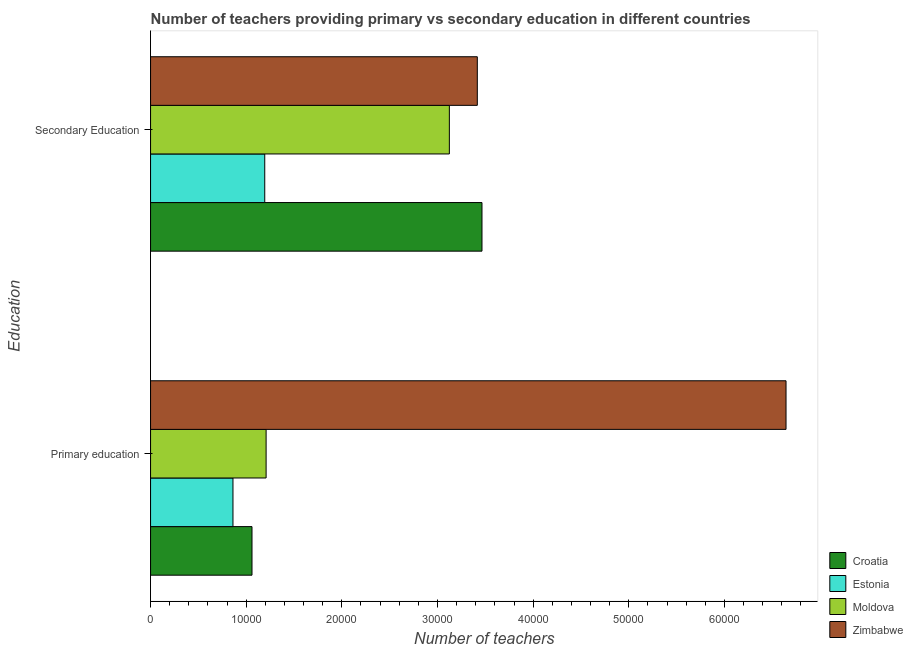How many groups of bars are there?
Your answer should be compact. 2. How many bars are there on the 2nd tick from the top?
Your response must be concise. 4. How many bars are there on the 2nd tick from the bottom?
Your response must be concise. 4. What is the number of primary teachers in Moldova?
Your answer should be compact. 1.21e+04. Across all countries, what is the maximum number of primary teachers?
Keep it short and to the point. 6.64e+04. Across all countries, what is the minimum number of primary teachers?
Give a very brief answer. 8616. In which country was the number of secondary teachers maximum?
Your response must be concise. Croatia. In which country was the number of secondary teachers minimum?
Make the answer very short. Estonia. What is the total number of secondary teachers in the graph?
Offer a terse response. 1.12e+05. What is the difference between the number of secondary teachers in Estonia and the number of primary teachers in Moldova?
Offer a terse response. -142. What is the average number of secondary teachers per country?
Offer a terse response. 2.80e+04. What is the difference between the number of secondary teachers and number of primary teachers in Croatia?
Provide a short and direct response. 2.40e+04. In how many countries, is the number of primary teachers greater than 4000 ?
Provide a succinct answer. 4. What is the ratio of the number of secondary teachers in Moldova to that in Estonia?
Your answer should be compact. 2.62. Is the number of primary teachers in Moldova less than that in Croatia?
Ensure brevity in your answer.  No. In how many countries, is the number of secondary teachers greater than the average number of secondary teachers taken over all countries?
Provide a short and direct response. 3. What does the 4th bar from the top in Primary education represents?
Give a very brief answer. Croatia. What does the 3rd bar from the bottom in Secondary Education represents?
Give a very brief answer. Moldova. Are all the bars in the graph horizontal?
Your response must be concise. Yes. How many countries are there in the graph?
Your answer should be compact. 4. Are the values on the major ticks of X-axis written in scientific E-notation?
Ensure brevity in your answer.  No. Does the graph contain any zero values?
Make the answer very short. No. Does the graph contain grids?
Your answer should be compact. No. Where does the legend appear in the graph?
Give a very brief answer. Bottom right. How are the legend labels stacked?
Your answer should be compact. Vertical. What is the title of the graph?
Offer a very short reply. Number of teachers providing primary vs secondary education in different countries. What is the label or title of the X-axis?
Keep it short and to the point. Number of teachers. What is the label or title of the Y-axis?
Your response must be concise. Education. What is the Number of teachers in Croatia in Primary education?
Your answer should be very brief. 1.06e+04. What is the Number of teachers in Estonia in Primary education?
Give a very brief answer. 8616. What is the Number of teachers in Moldova in Primary education?
Your answer should be compact. 1.21e+04. What is the Number of teachers of Zimbabwe in Primary education?
Make the answer very short. 6.64e+04. What is the Number of teachers of Croatia in Secondary Education?
Your response must be concise. 3.47e+04. What is the Number of teachers in Estonia in Secondary Education?
Ensure brevity in your answer.  1.19e+04. What is the Number of teachers in Moldova in Secondary Education?
Your answer should be very brief. 3.12e+04. What is the Number of teachers of Zimbabwe in Secondary Education?
Your response must be concise. 3.42e+04. Across all Education, what is the maximum Number of teachers in Croatia?
Keep it short and to the point. 3.47e+04. Across all Education, what is the maximum Number of teachers of Estonia?
Provide a succinct answer. 1.19e+04. Across all Education, what is the maximum Number of teachers in Moldova?
Your answer should be very brief. 3.12e+04. Across all Education, what is the maximum Number of teachers of Zimbabwe?
Provide a short and direct response. 6.64e+04. Across all Education, what is the minimum Number of teachers in Croatia?
Your answer should be compact. 1.06e+04. Across all Education, what is the minimum Number of teachers of Estonia?
Offer a very short reply. 8616. Across all Education, what is the minimum Number of teachers in Moldova?
Provide a short and direct response. 1.21e+04. Across all Education, what is the minimum Number of teachers in Zimbabwe?
Your answer should be compact. 3.42e+04. What is the total Number of teachers of Croatia in the graph?
Your answer should be very brief. 4.53e+04. What is the total Number of teachers of Estonia in the graph?
Provide a short and direct response. 2.06e+04. What is the total Number of teachers of Moldova in the graph?
Offer a terse response. 4.33e+04. What is the total Number of teachers of Zimbabwe in the graph?
Offer a very short reply. 1.01e+05. What is the difference between the Number of teachers of Croatia in Primary education and that in Secondary Education?
Ensure brevity in your answer.  -2.40e+04. What is the difference between the Number of teachers in Estonia in Primary education and that in Secondary Education?
Provide a succinct answer. -3322. What is the difference between the Number of teachers in Moldova in Primary education and that in Secondary Education?
Your answer should be compact. -1.92e+04. What is the difference between the Number of teachers of Zimbabwe in Primary education and that in Secondary Education?
Provide a succinct answer. 3.23e+04. What is the difference between the Number of teachers in Croatia in Primary education and the Number of teachers in Estonia in Secondary Education?
Provide a succinct answer. -1333. What is the difference between the Number of teachers of Croatia in Primary education and the Number of teachers of Moldova in Secondary Education?
Make the answer very short. -2.06e+04. What is the difference between the Number of teachers of Croatia in Primary education and the Number of teachers of Zimbabwe in Secondary Education?
Your answer should be very brief. -2.36e+04. What is the difference between the Number of teachers in Estonia in Primary education and the Number of teachers in Moldova in Secondary Education?
Provide a short and direct response. -2.26e+04. What is the difference between the Number of teachers in Estonia in Primary education and the Number of teachers in Zimbabwe in Secondary Education?
Offer a terse response. -2.55e+04. What is the difference between the Number of teachers in Moldova in Primary education and the Number of teachers in Zimbabwe in Secondary Education?
Your answer should be very brief. -2.21e+04. What is the average Number of teachers of Croatia per Education?
Ensure brevity in your answer.  2.26e+04. What is the average Number of teachers of Estonia per Education?
Provide a short and direct response. 1.03e+04. What is the average Number of teachers of Moldova per Education?
Your answer should be very brief. 2.17e+04. What is the average Number of teachers of Zimbabwe per Education?
Ensure brevity in your answer.  5.03e+04. What is the difference between the Number of teachers in Croatia and Number of teachers in Estonia in Primary education?
Offer a terse response. 1989. What is the difference between the Number of teachers of Croatia and Number of teachers of Moldova in Primary education?
Offer a terse response. -1475. What is the difference between the Number of teachers in Croatia and Number of teachers in Zimbabwe in Primary education?
Provide a short and direct response. -5.58e+04. What is the difference between the Number of teachers in Estonia and Number of teachers in Moldova in Primary education?
Provide a short and direct response. -3464. What is the difference between the Number of teachers in Estonia and Number of teachers in Zimbabwe in Primary education?
Give a very brief answer. -5.78e+04. What is the difference between the Number of teachers in Moldova and Number of teachers in Zimbabwe in Primary education?
Your response must be concise. -5.44e+04. What is the difference between the Number of teachers of Croatia and Number of teachers of Estonia in Secondary Education?
Keep it short and to the point. 2.27e+04. What is the difference between the Number of teachers of Croatia and Number of teachers of Moldova in Secondary Education?
Offer a terse response. 3411. What is the difference between the Number of teachers in Croatia and Number of teachers in Zimbabwe in Secondary Education?
Your answer should be compact. 488. What is the difference between the Number of teachers of Estonia and Number of teachers of Moldova in Secondary Education?
Give a very brief answer. -1.93e+04. What is the difference between the Number of teachers in Estonia and Number of teachers in Zimbabwe in Secondary Education?
Give a very brief answer. -2.22e+04. What is the difference between the Number of teachers in Moldova and Number of teachers in Zimbabwe in Secondary Education?
Ensure brevity in your answer.  -2923. What is the ratio of the Number of teachers in Croatia in Primary education to that in Secondary Education?
Make the answer very short. 0.31. What is the ratio of the Number of teachers in Estonia in Primary education to that in Secondary Education?
Provide a short and direct response. 0.72. What is the ratio of the Number of teachers of Moldova in Primary education to that in Secondary Education?
Your answer should be very brief. 0.39. What is the ratio of the Number of teachers in Zimbabwe in Primary education to that in Secondary Education?
Keep it short and to the point. 1.94. What is the difference between the highest and the second highest Number of teachers of Croatia?
Provide a short and direct response. 2.40e+04. What is the difference between the highest and the second highest Number of teachers of Estonia?
Provide a succinct answer. 3322. What is the difference between the highest and the second highest Number of teachers of Moldova?
Your answer should be very brief. 1.92e+04. What is the difference between the highest and the second highest Number of teachers in Zimbabwe?
Keep it short and to the point. 3.23e+04. What is the difference between the highest and the lowest Number of teachers in Croatia?
Keep it short and to the point. 2.40e+04. What is the difference between the highest and the lowest Number of teachers in Estonia?
Your answer should be very brief. 3322. What is the difference between the highest and the lowest Number of teachers in Moldova?
Provide a succinct answer. 1.92e+04. What is the difference between the highest and the lowest Number of teachers in Zimbabwe?
Offer a very short reply. 3.23e+04. 